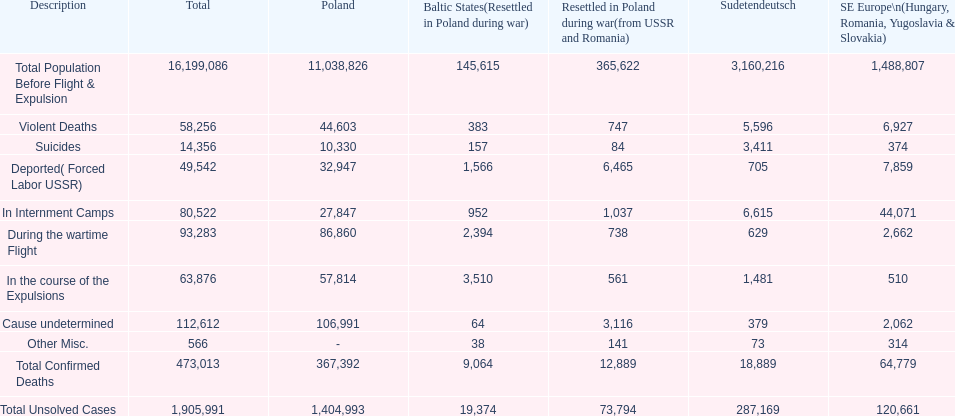What is the aggregate amount of mortalities in internment facilities and amidst the wartime exodus? 173,805. 